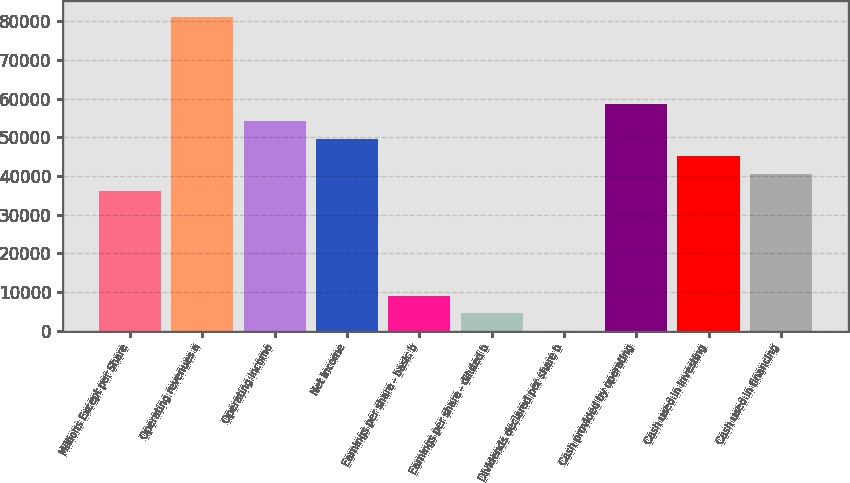<chart> <loc_0><loc_0><loc_500><loc_500><bar_chart><fcel>Millions Except per Share<fcel>Operating revenues a<fcel>Operating income<fcel>Net income<fcel>Earnings per share - basic b<fcel>Earnings per share - diluted b<fcel>Dividends declared per share b<fcel>Cash provided by operating<fcel>Cash used in investing<fcel>Cash used in financing<nl><fcel>36077<fcel>81172<fcel>54115<fcel>49605.5<fcel>9019.96<fcel>4510.46<fcel>0.96<fcel>58624.5<fcel>45096<fcel>40586.5<nl></chart> 